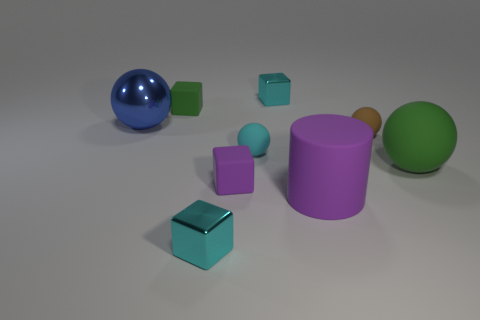Is there another large cylinder that has the same color as the cylinder?
Keep it short and to the point. No. What number of objects are small shiny cubes in front of the tiny green thing or big purple shiny spheres?
Make the answer very short. 1. What number of other objects are there of the same size as the cyan ball?
Provide a succinct answer. 5. What is the material of the cyan block that is behind the tiny cyan shiny object that is on the left side of the cyan metallic cube that is on the right side of the small cyan sphere?
Your answer should be compact. Metal. What number of cylinders are big blue metal things or large red things?
Keep it short and to the point. 0. Is there any other thing that has the same shape as the small brown thing?
Your answer should be very brief. Yes. Is the number of matte objects that are behind the tiny purple block greater than the number of large green rubber things that are behind the small brown object?
Offer a terse response. Yes. How many small metal cubes are in front of the big thing that is to the left of the cylinder?
Make the answer very short. 1. How many things are either tiny purple rubber cubes or tiny yellow spheres?
Provide a succinct answer. 1. Does the tiny purple thing have the same shape as the big blue shiny thing?
Your answer should be compact. No. 